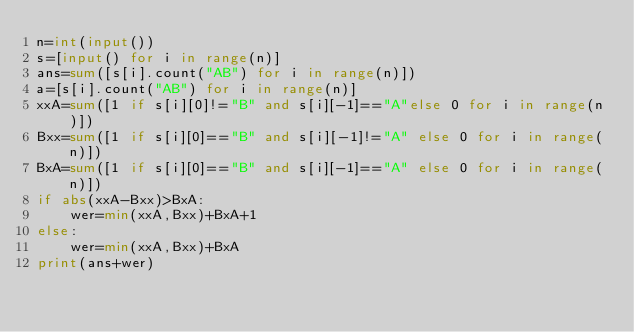Convert code to text. <code><loc_0><loc_0><loc_500><loc_500><_Python_>n=int(input())
s=[input() for i in range(n)]
ans=sum([s[i].count("AB") for i in range(n)])
a=[s[i].count("AB") for i in range(n)]
xxA=sum([1 if s[i][0]!="B" and s[i][-1]=="A"else 0 for i in range(n)])
Bxx=sum([1 if s[i][0]=="B" and s[i][-1]!="A" else 0 for i in range(n)])
BxA=sum([1 if s[i][0]=="B" and s[i][-1]=="A" else 0 for i in range(n)])
if abs(xxA-Bxx)>BxA:
    wer=min(xxA,Bxx)+BxA+1
else:
    wer=min(xxA,Bxx)+BxA
print(ans+wer)</code> 